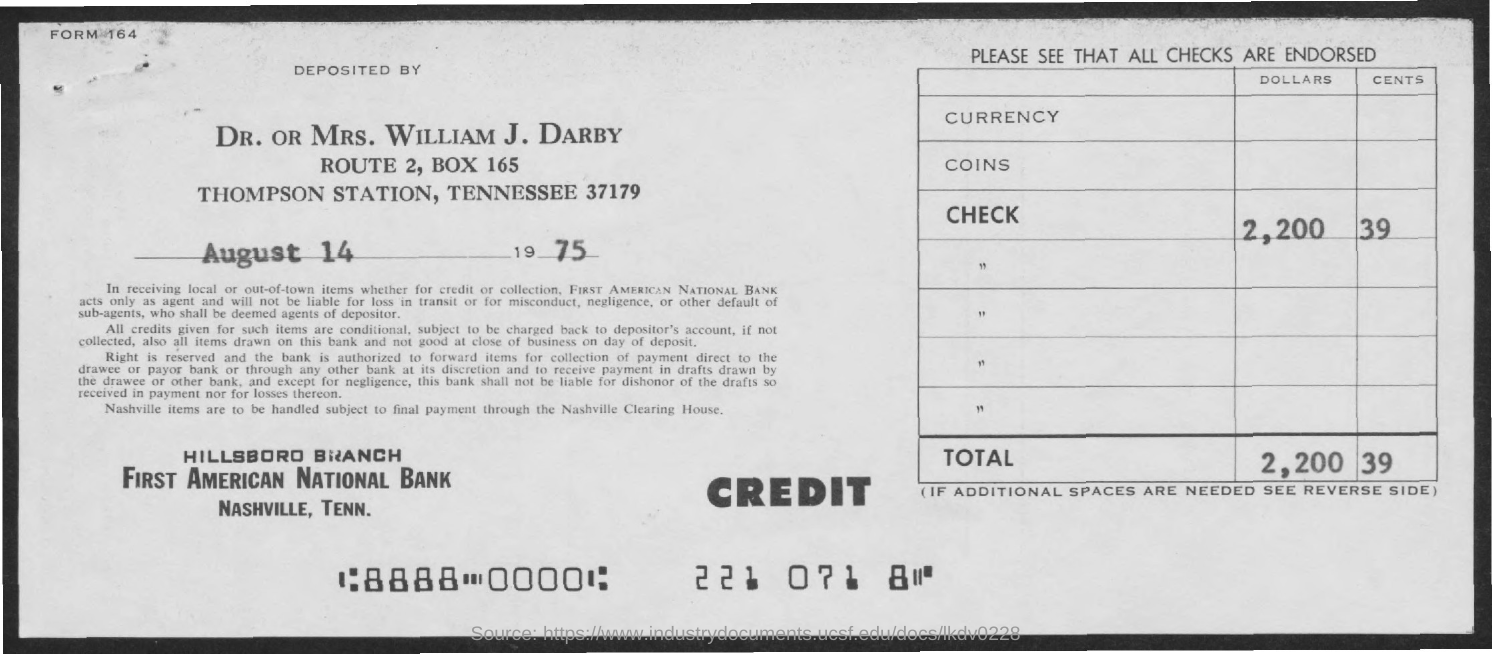Outline some significant characteristics in this image. The deposit date mentioned in the form is August 14, 1975. What is the form number indicated in the header of the document? The check amount mentioned in the form is $2,200.39. First American National Bank's form is given here. DR. OR MRS. WILLIAM J. DARBY has deposited the check amount as per the form. 